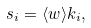Convert formula to latex. <formula><loc_0><loc_0><loc_500><loc_500>s _ { i } = \langle w \rangle k _ { i } ,</formula> 